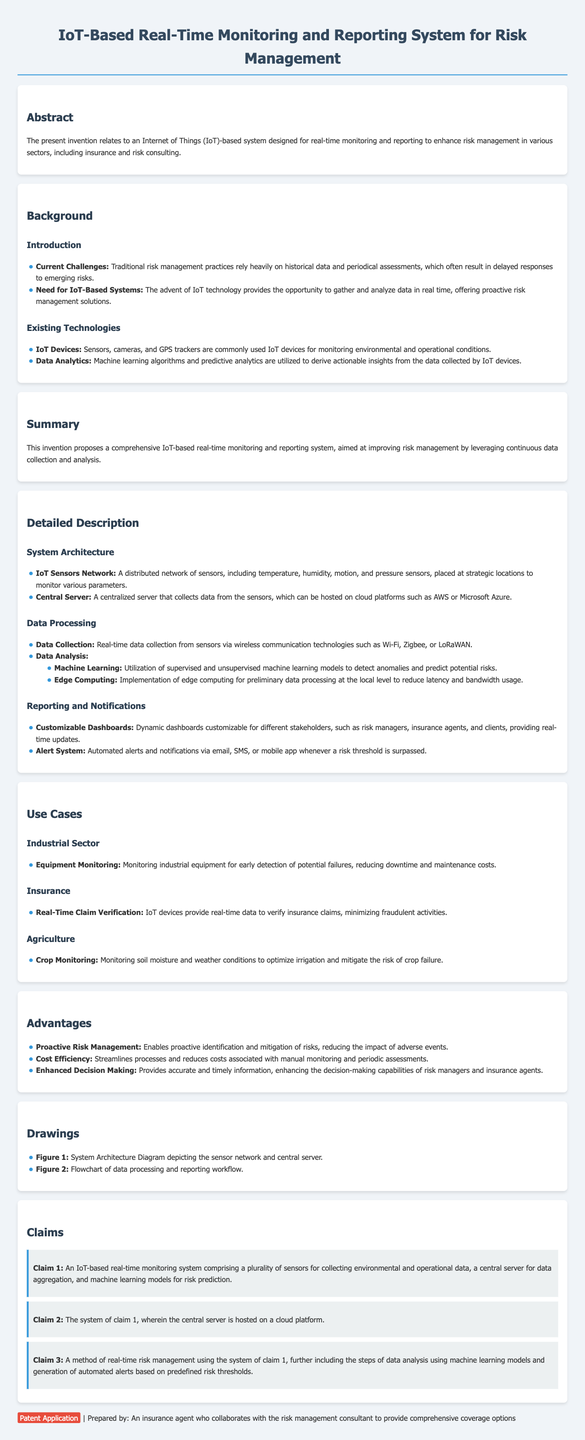What is the title of the patent application? The title of the patent application is stated prominently at the top of the document.
Answer: IoT-Based Real-Time Monitoring and Reporting System for Risk Management What technology does the system utilize? The technology utilized in the system is mentioned in the abstract and throughout the document.
Answer: Internet of Things (IoT) How many claims are included in the patent application? The claims section explicitly lists the number of claims made in the document.
Answer: Three What is the primary purpose of the invention? The primary purpose is revealed in the summary and abstract sections of the document.
Answer: Improve risk management What type of data analytics is mentioned in the document? The document includes specific types of analytics mentioned under data processing.
Answer: Machine learning What is one advantage of the proposed system? The advantages are listed in the designated section, explaining the benefits of the system.
Answer: Proactive Risk Management Who are the intended users of the customizable dashboards? The dashboard section specifies the different stakeholders that can utilize the information.
Answer: Risk managers, insurance agents, and clients What is the function of the alert system? The function of the alert system is detailed in the reporting and notifications section.
Answer: Automated alerts and notifications Which sectors could benefit from this system? The use cases section lists the sectors that could utilize the proposed system.
Answer: Industrial, Insurance, Agriculture 